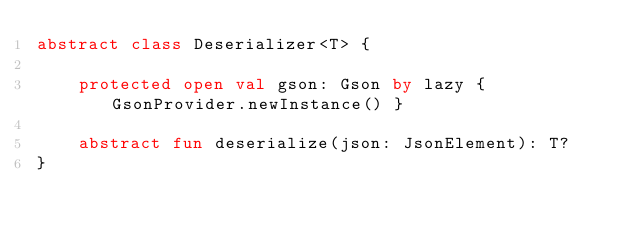Convert code to text. <code><loc_0><loc_0><loc_500><loc_500><_Kotlin_>abstract class Deserializer<T> {

    protected open val gson: Gson by lazy { GsonProvider.newInstance() }

    abstract fun deserialize(json: JsonElement): T?
}
</code> 